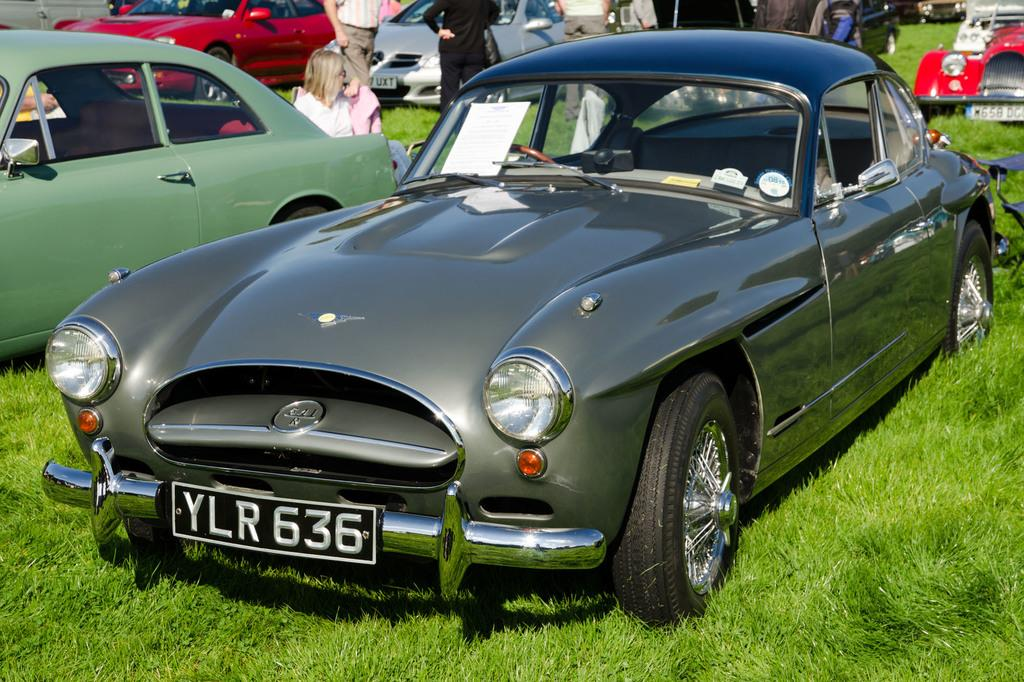Where was the image taken? The image was clicked outside. What can be seen in the foreground of the image? There is green grass and vehicles parked on the ground in the foreground. What is visible in the background of the image? There is a group of persons in the background of the image. What type of bead is being used to decorate the cakes in the image? There are no cakes or beads present in the image. What record is being played in the background of the image? There is no record or music being played in the image. 